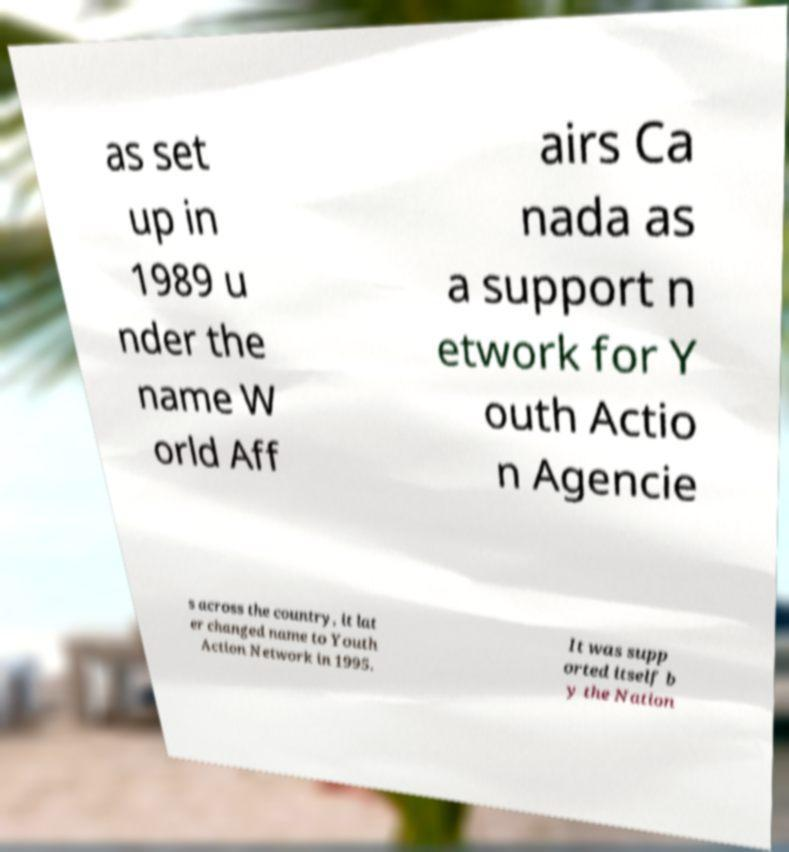There's text embedded in this image that I need extracted. Can you transcribe it verbatim? as set up in 1989 u nder the name W orld Aff airs Ca nada as a support n etwork for Y outh Actio n Agencie s across the country, it lat er changed name to Youth Action Network in 1995. It was supp orted itself b y the Nation 